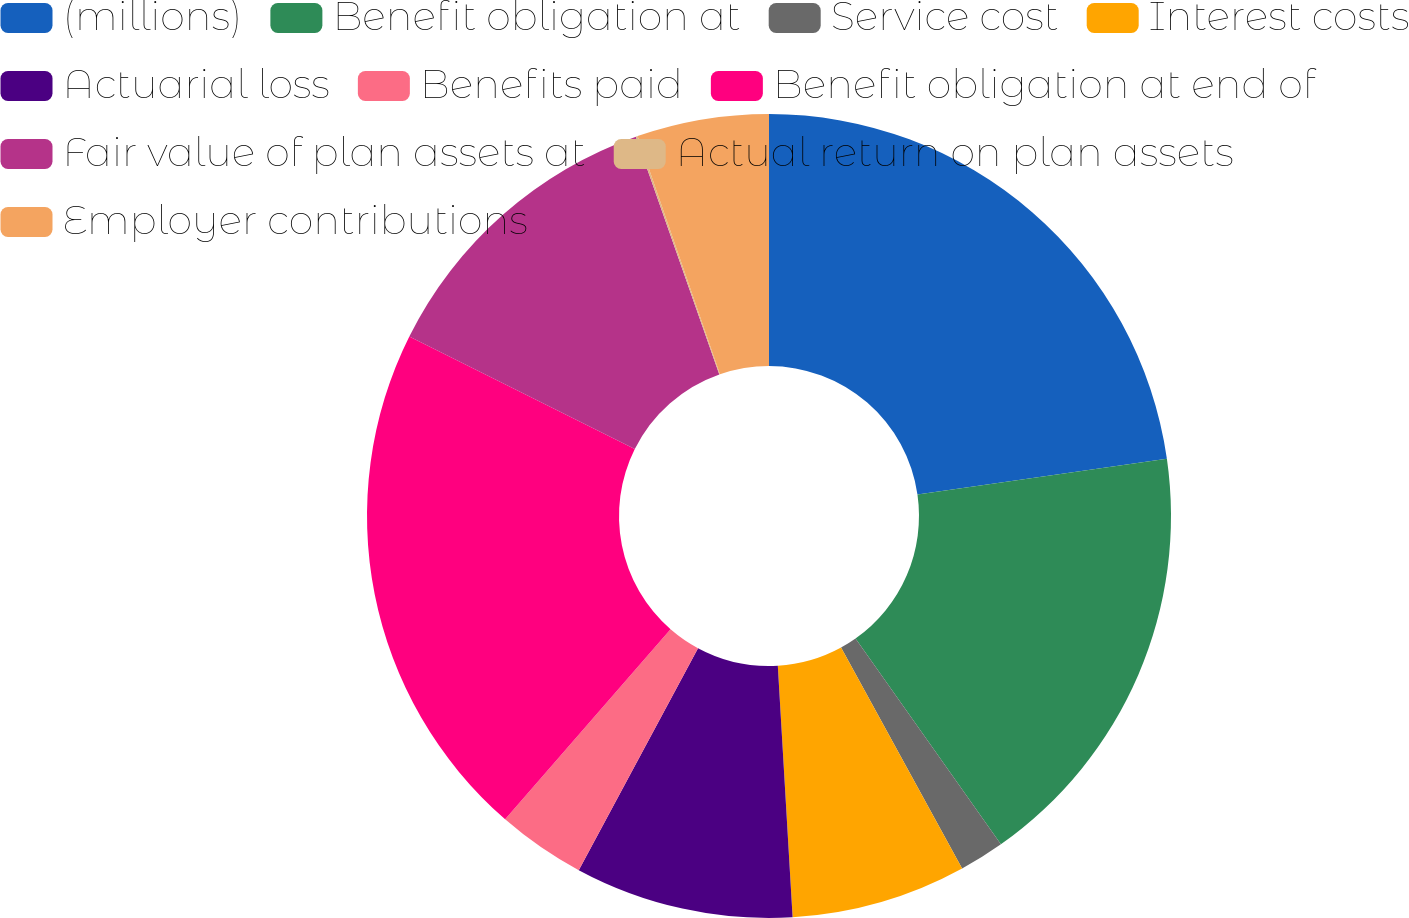Convert chart. <chart><loc_0><loc_0><loc_500><loc_500><pie_chart><fcel>(millions)<fcel>Benefit obligation at<fcel>Service cost<fcel>Interest costs<fcel>Actuarial loss<fcel>Benefits paid<fcel>Benefit obligation at end of<fcel>Fair value of plan assets at<fcel>Actual return on plan assets<fcel>Employer contributions<nl><fcel>22.72%<fcel>17.49%<fcel>1.81%<fcel>7.04%<fcel>8.78%<fcel>3.55%<fcel>20.97%<fcel>12.26%<fcel>0.07%<fcel>5.3%<nl></chart> 